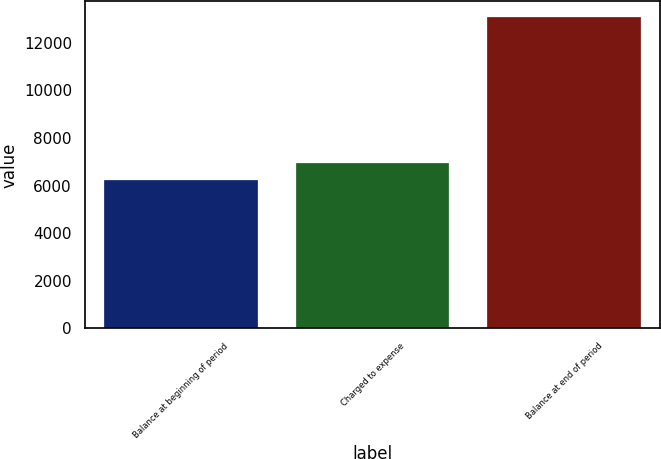Convert chart. <chart><loc_0><loc_0><loc_500><loc_500><bar_chart><fcel>Balance at beginning of period<fcel>Charged to expense<fcel>Balance at end of period<nl><fcel>6255<fcel>6938.8<fcel>13093<nl></chart> 